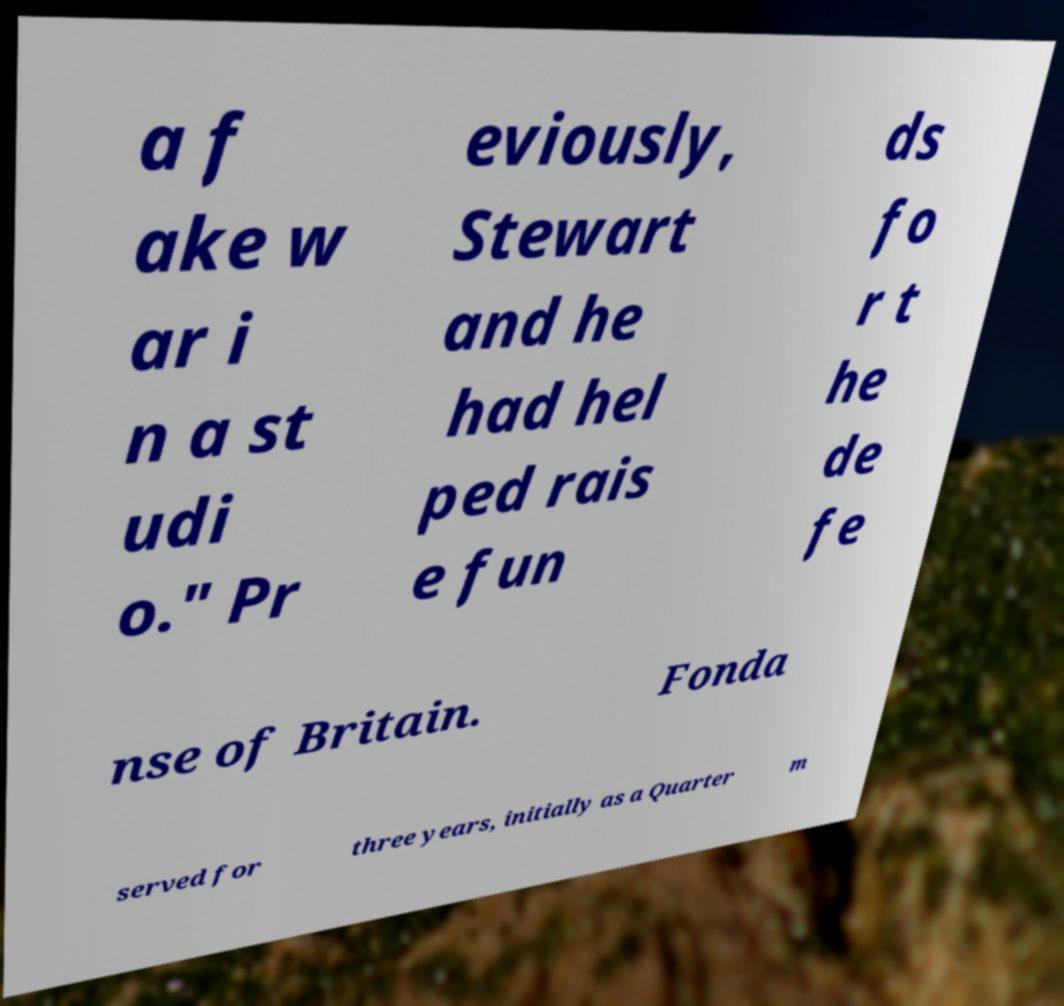There's text embedded in this image that I need extracted. Can you transcribe it verbatim? a f ake w ar i n a st udi o." Pr eviously, Stewart and he had hel ped rais e fun ds fo r t he de fe nse of Britain. Fonda served for three years, initially as a Quarter m 